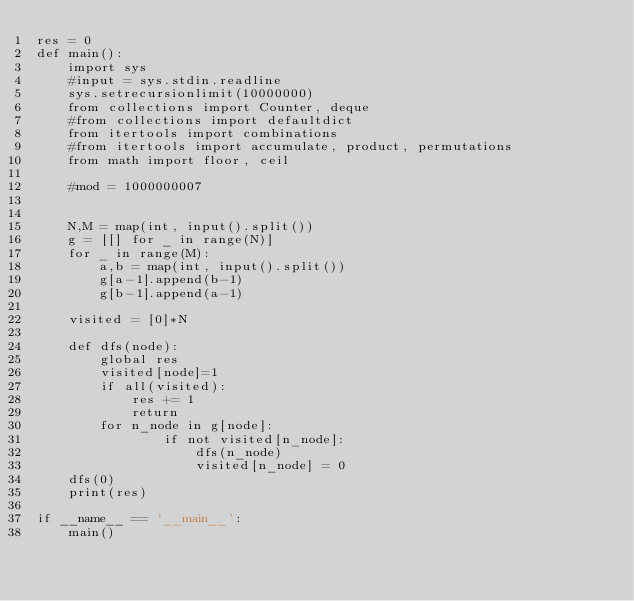Convert code to text. <code><loc_0><loc_0><loc_500><loc_500><_Python_>res = 0
def main():
    import sys
    #input = sys.stdin.readline
    sys.setrecursionlimit(10000000)
    from collections import Counter, deque
    #from collections import defaultdict
    from itertools import combinations
    #from itertools import accumulate, product, permutations
    from math import floor, ceil

    #mod = 1000000007


    N,M = map(int, input().split())
    g = [[] for _ in range(N)]
    for _ in range(M):
        a,b = map(int, input().split())
        g[a-1].append(b-1)
        g[b-1].append(a-1)

    visited = [0]*N

    def dfs(node):
        global res
        visited[node]=1
        if all(visited):
            res += 1
            return
        for n_node in g[node]:
                if not visited[n_node]:
                    dfs(n_node)
                    visited[n_node] = 0
    dfs(0)
    print(res)

if __name__ == '__main__':
    main()
</code> 